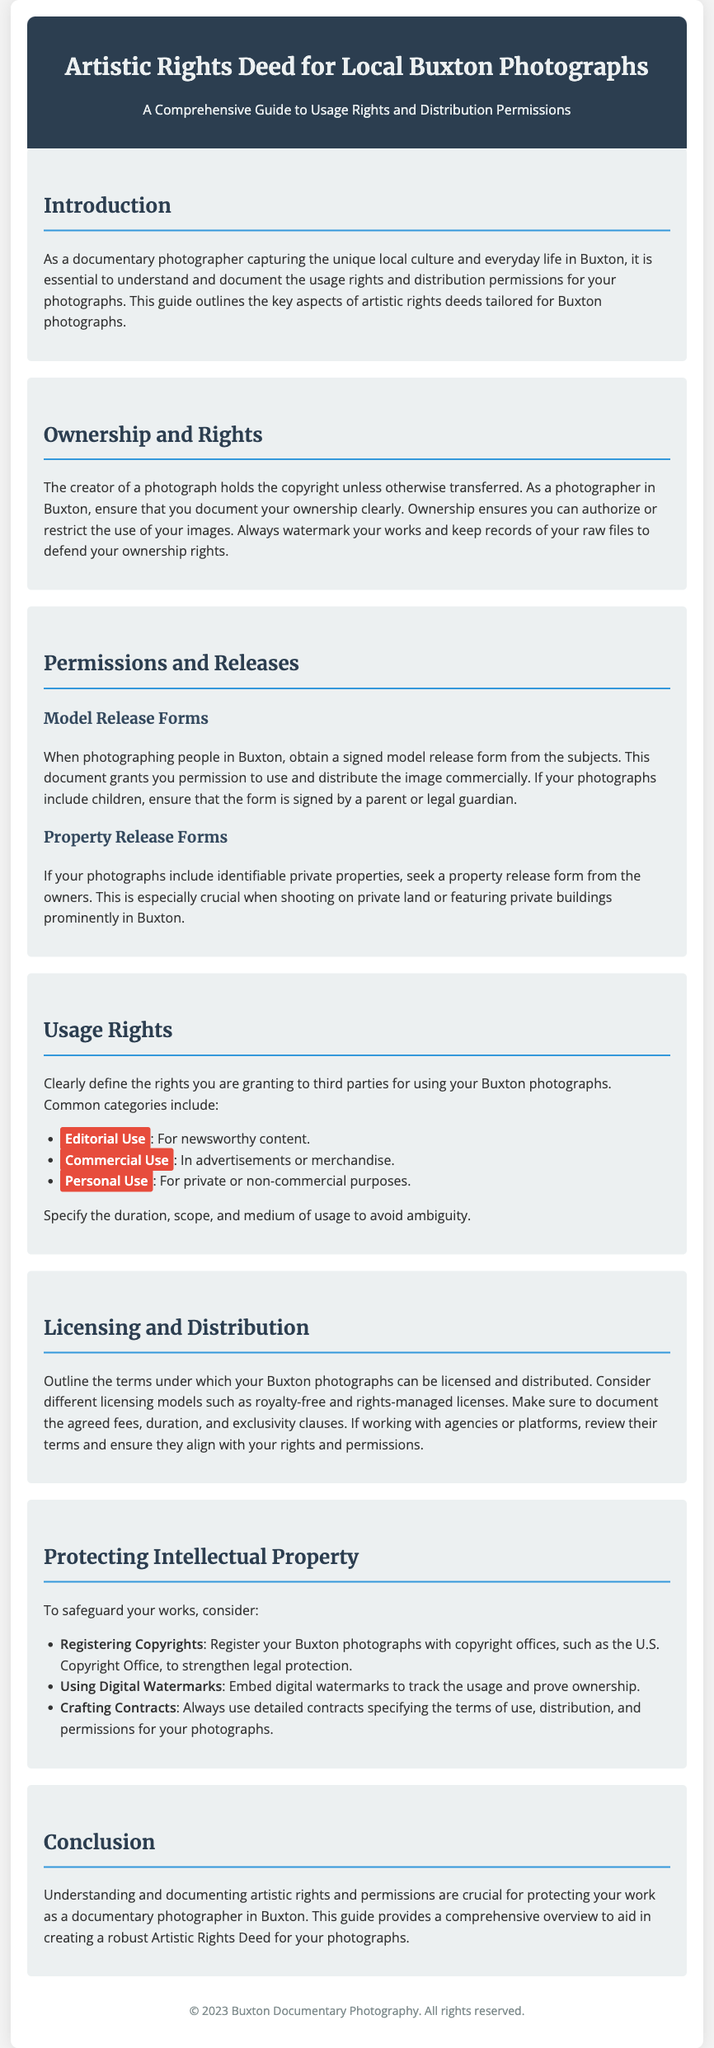What is the title of the document? The title of the document is found in the header section.
Answer: Artistic Rights Deed for Local Buxton Photographs What must a photographer in Buxton do to document their ownership? This information is mentioned in the section about Ownership and Rights, specifically regarding watermarking and record-keeping.
Answer: Watermark their works and keep records of raw files What form is required when photographing people? This is outlined in the Permissions and Releases section, mentioning consent for usage and distribution.
Answer: Model release form What is one key significance of a property release form? The significance is described in the Permissions and Releases section concerning identifiable properties in photographs.
Answer: Grants permission for use of private properties Which type of use is described for newsworthy content? The usage rights section lists different categories of use, including editorial.
Answer: Editorial Use What should be documented in the licensing terms? The Licensing and Distribution section emphasizes specific elements that need documentation for licensing agreements.
Answer: Agreed fees, duration, and exclusivity clauses How can a photographer protect their photographs legally? The Protecting Intellectual Property section provides several methods for legal protection.
Answer: Registering Copyrights What digital method is suggested to prove ownership? This information is mentioned in the Protecting Intellectual Property section about safeguarding works.
Answer: Digital Watermarks What is the main purpose of this document? The introduction outlines the primary goal of the guide for photographers in Buxton.
Answer: Protecting your work as a documentary photographer 